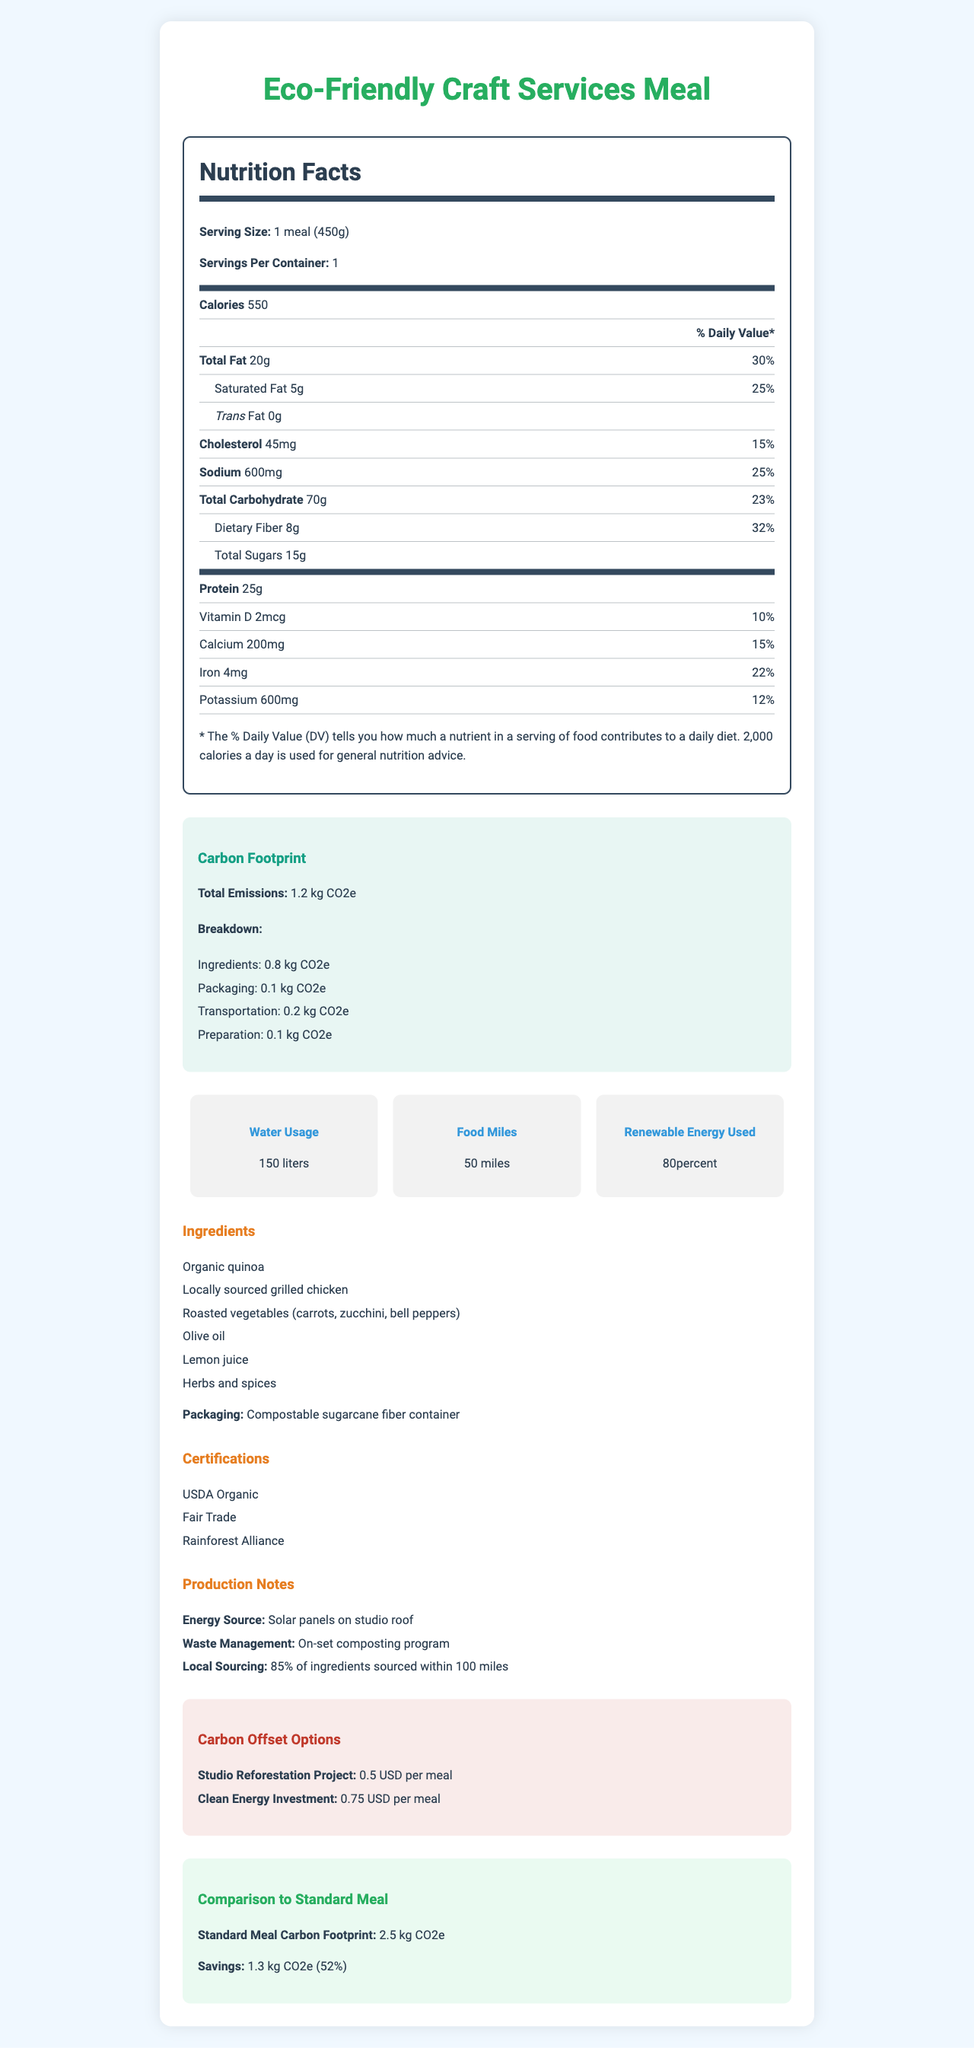what is the serving size of the Eco-Friendly Craft Services Meal? The serving size is explicitly mentioned as "1 meal (450g)" in the nutrition label section of the document.
Answer: 1 meal (450g) How many calories are in one serving of the meal? The document lists the calorie content as 550 calories per serving under the nutrition facts section.
Answer: 550 What is the percentage of daily value for saturated fat? The document indicates that saturated fat makes up 25% of the daily value, based on the value of 5g out of the daily recommended 20g.
Answer: 25% What is the total carbon footprint of the meal in kg CO2e? The carbon footprint section states that the total emissions amount to 1.2 kg CO2e.
Answer: 1.2 kg CO2e How much water is used to produce this meal? The sustainability metrics section specifies that 150 liters of water are used.
Answer: 150 liters What are the three main components contributing to the carbon footprint of the meal? A. Ingredients, Packaging, Preparation B. Ingredients, Transportation, Preparation C. Ingredients, Packaging, Transportation The carbon footprint breakdown lists ingredients (0.8 kg CO2e), packaging (0.1 kg CO2e), and transportation (0.2 kg CO2e) as the main contributors.
Answer: C What percentage of the meal's energy usage comes from renewable sources? A. 50% B. 70% C. 80% The sustainability metrics section states that 80% of the energy used comes from renewable sources.
Answer: C Is the packaging for the meal compostable? The document mentions that the packaging is a "Compostable sugarcane fiber container."
Answer: Yes What are the certifications associated with this meal? The certifications section lists these three certifications explicitly.
Answer: USDA Organic, Fair Trade, Rainforest Alliance Summarize the main idea of the document. The document combines nutritional facts with environmental and sustainability information, highlighting the meal’s low carbon footprint, water usage, renewable energy utilization, compostable packaging, and certifications, all while comparing it to a standard meal.
Answer: The document provides a detailed nutritional breakdown, carbon footprint analysis, sustainability metrics, ingredient list, certifications, and production notes for the Eco-Friendly Craft Services Meal. What percentage of the meal's ingredients are sourced locally? The production notes section explicitly states that 85% of the ingredients are sourced within 100 miles.
Answer: 85% What is the carbon footprint comparison between the Eco-Friendly meal and a standard meal? The comparison section specifies that the standard meal has a carbon footprint of 2.5 kg CO2e, and that the Eco-Friendly meal saves 1.3 kg CO2e (which is a 52% reduction).
Answer: The Eco-Friendly meal saves 1.3 kg CO2e compared to a standard meal, which has a carbon footprint of 2.5 kg CO2e. Why is this meal considered sustainable? The document highlights various aspects that contribute to its sustainability, including a detailed carbon footprint breakdown, high percentage of renewable energy use, local ingredient sourcing, compostable packaging, and official certifications.
Answer: Multiple reasons: low carbon footprint, renewable energy use, local sourcing, compostable packaging, and certifications What is the cholesterol content in the meal? The nutrition facts list 45 mg of cholesterol per serving.
Answer: 45mg What is the carbon footprint from the meal's packaging? The carbon footprint breakdown lists packaging emissions at 0.1 kg CO2e.
Answer: 0.1 kg CO2e What type of energy sources the meal’s production facility? The production notes mention that the energy source is solar panels installed on the studio roof.
Answer: Solar panels on studio roof What is the sodium content as a percentage of daily value? The sodium content is listed as 600 mg, which is 25% of the daily value based on the recommended 2400 mg.
Answer: 25% What is the exact source of the grilled chicken used in the meal? The document mentions that grilled chicken is locally sourced but does not provide an exact source.
Answer: Not enough information Which certification indicates the meal’s ingredients are grown without certain pesticides and chemicals? The USDA Organic certification confirms that the ingredients are grown without certain pesticides and chemicals.
Answer: USDA Organic For a one-time carbon offset, what is the cheapest option available? The carbon offset options list the Studio Reforestation Project as the cheaper option at 0.5 USD per meal.
Answer: Studio Reforestation Project at 0.5 USD per meal By how many miles are the ingredients sourced locally for this meal? The production notes mention local sourcing is within 100 miles.
Answer: Ingredients are sourced within 100 miles 